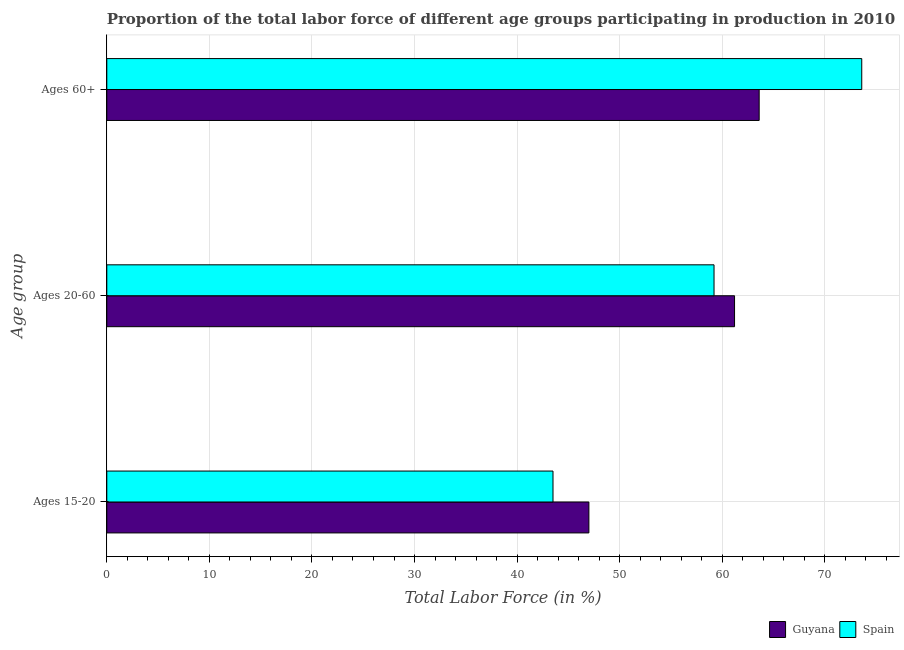How many different coloured bars are there?
Make the answer very short. 2. How many groups of bars are there?
Offer a terse response. 3. Are the number of bars per tick equal to the number of legend labels?
Make the answer very short. Yes. Are the number of bars on each tick of the Y-axis equal?
Provide a succinct answer. Yes. How many bars are there on the 2nd tick from the top?
Offer a very short reply. 2. What is the label of the 1st group of bars from the top?
Offer a very short reply. Ages 60+. What is the percentage of labor force within the age group 15-20 in Spain?
Your response must be concise. 43.5. Across all countries, what is the maximum percentage of labor force within the age group 20-60?
Make the answer very short. 61.2. Across all countries, what is the minimum percentage of labor force within the age group 20-60?
Offer a very short reply. 59.2. In which country was the percentage of labor force within the age group 20-60 minimum?
Give a very brief answer. Spain. What is the total percentage of labor force above age 60 in the graph?
Offer a terse response. 137.2. What is the difference between the percentage of labor force above age 60 in Guyana and that in Spain?
Keep it short and to the point. -10. What is the difference between the percentage of labor force within the age group 20-60 in Guyana and the percentage of labor force above age 60 in Spain?
Offer a terse response. -12.4. What is the average percentage of labor force above age 60 per country?
Give a very brief answer. 68.6. What is the difference between the percentage of labor force within the age group 20-60 and percentage of labor force within the age group 15-20 in Guyana?
Offer a very short reply. 14.2. In how many countries, is the percentage of labor force above age 60 greater than 42 %?
Your response must be concise. 2. What is the ratio of the percentage of labor force within the age group 15-20 in Spain to that in Guyana?
Ensure brevity in your answer.  0.93. What is the difference between the highest and the second highest percentage of labor force above age 60?
Keep it short and to the point. 10. In how many countries, is the percentage of labor force within the age group 20-60 greater than the average percentage of labor force within the age group 20-60 taken over all countries?
Provide a short and direct response. 1. Is the sum of the percentage of labor force above age 60 in Spain and Guyana greater than the maximum percentage of labor force within the age group 15-20 across all countries?
Provide a succinct answer. Yes. What does the 1st bar from the top in Ages 60+ represents?
Offer a very short reply. Spain. What is the difference between two consecutive major ticks on the X-axis?
Your answer should be very brief. 10. Are the values on the major ticks of X-axis written in scientific E-notation?
Give a very brief answer. No. Does the graph contain any zero values?
Offer a terse response. No. Does the graph contain grids?
Make the answer very short. Yes. How are the legend labels stacked?
Provide a short and direct response. Horizontal. What is the title of the graph?
Offer a terse response. Proportion of the total labor force of different age groups participating in production in 2010. What is the label or title of the X-axis?
Your answer should be very brief. Total Labor Force (in %). What is the label or title of the Y-axis?
Ensure brevity in your answer.  Age group. What is the Total Labor Force (in %) of Guyana in Ages 15-20?
Your answer should be compact. 47. What is the Total Labor Force (in %) of Spain in Ages 15-20?
Give a very brief answer. 43.5. What is the Total Labor Force (in %) of Guyana in Ages 20-60?
Offer a very short reply. 61.2. What is the Total Labor Force (in %) of Spain in Ages 20-60?
Offer a terse response. 59.2. What is the Total Labor Force (in %) in Guyana in Ages 60+?
Offer a very short reply. 63.6. What is the Total Labor Force (in %) in Spain in Ages 60+?
Offer a terse response. 73.6. Across all Age group, what is the maximum Total Labor Force (in %) in Guyana?
Make the answer very short. 63.6. Across all Age group, what is the maximum Total Labor Force (in %) in Spain?
Make the answer very short. 73.6. Across all Age group, what is the minimum Total Labor Force (in %) of Guyana?
Offer a very short reply. 47. Across all Age group, what is the minimum Total Labor Force (in %) of Spain?
Offer a very short reply. 43.5. What is the total Total Labor Force (in %) of Guyana in the graph?
Ensure brevity in your answer.  171.8. What is the total Total Labor Force (in %) in Spain in the graph?
Offer a very short reply. 176.3. What is the difference between the Total Labor Force (in %) in Spain in Ages 15-20 and that in Ages 20-60?
Offer a very short reply. -15.7. What is the difference between the Total Labor Force (in %) in Guyana in Ages 15-20 and that in Ages 60+?
Make the answer very short. -16.6. What is the difference between the Total Labor Force (in %) in Spain in Ages 15-20 and that in Ages 60+?
Your response must be concise. -30.1. What is the difference between the Total Labor Force (in %) in Spain in Ages 20-60 and that in Ages 60+?
Your answer should be very brief. -14.4. What is the difference between the Total Labor Force (in %) in Guyana in Ages 15-20 and the Total Labor Force (in %) in Spain in Ages 60+?
Ensure brevity in your answer.  -26.6. What is the difference between the Total Labor Force (in %) of Guyana in Ages 20-60 and the Total Labor Force (in %) of Spain in Ages 60+?
Make the answer very short. -12.4. What is the average Total Labor Force (in %) of Guyana per Age group?
Give a very brief answer. 57.27. What is the average Total Labor Force (in %) in Spain per Age group?
Offer a very short reply. 58.77. What is the difference between the Total Labor Force (in %) of Guyana and Total Labor Force (in %) of Spain in Ages 15-20?
Give a very brief answer. 3.5. What is the difference between the Total Labor Force (in %) of Guyana and Total Labor Force (in %) of Spain in Ages 20-60?
Ensure brevity in your answer.  2. What is the ratio of the Total Labor Force (in %) of Guyana in Ages 15-20 to that in Ages 20-60?
Make the answer very short. 0.77. What is the ratio of the Total Labor Force (in %) in Spain in Ages 15-20 to that in Ages 20-60?
Offer a very short reply. 0.73. What is the ratio of the Total Labor Force (in %) of Guyana in Ages 15-20 to that in Ages 60+?
Keep it short and to the point. 0.74. What is the ratio of the Total Labor Force (in %) in Spain in Ages 15-20 to that in Ages 60+?
Offer a terse response. 0.59. What is the ratio of the Total Labor Force (in %) in Guyana in Ages 20-60 to that in Ages 60+?
Your answer should be very brief. 0.96. What is the ratio of the Total Labor Force (in %) of Spain in Ages 20-60 to that in Ages 60+?
Your response must be concise. 0.8. What is the difference between the highest and the lowest Total Labor Force (in %) in Guyana?
Your answer should be very brief. 16.6. What is the difference between the highest and the lowest Total Labor Force (in %) in Spain?
Ensure brevity in your answer.  30.1. 